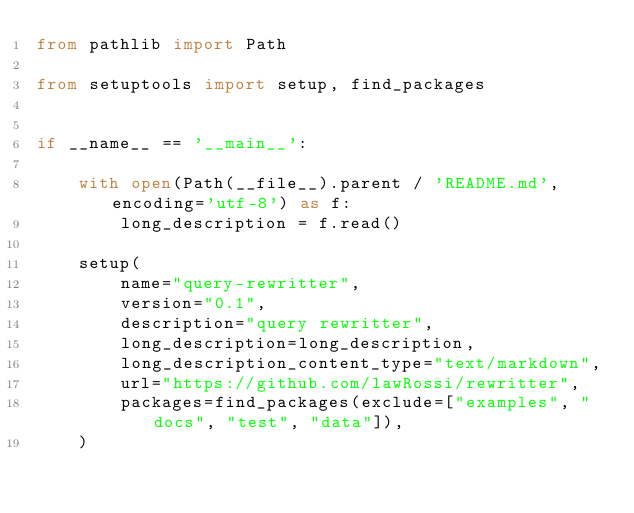Convert code to text. <code><loc_0><loc_0><loc_500><loc_500><_Python_>from pathlib import Path

from setuptools import setup, find_packages


if __name__ == '__main__':

    with open(Path(__file__).parent / 'README.md', encoding='utf-8') as f:
        long_description = f.read()

    setup(
        name="query-rewritter",
        version="0.1",
        description="query rewritter",
        long_description=long_description,
        long_description_content_type="text/markdown",
        url="https://github.com/lawRossi/rewritter",
        packages=find_packages(exclude=["examples", "docs", "test", "data"]),
    )
</code> 